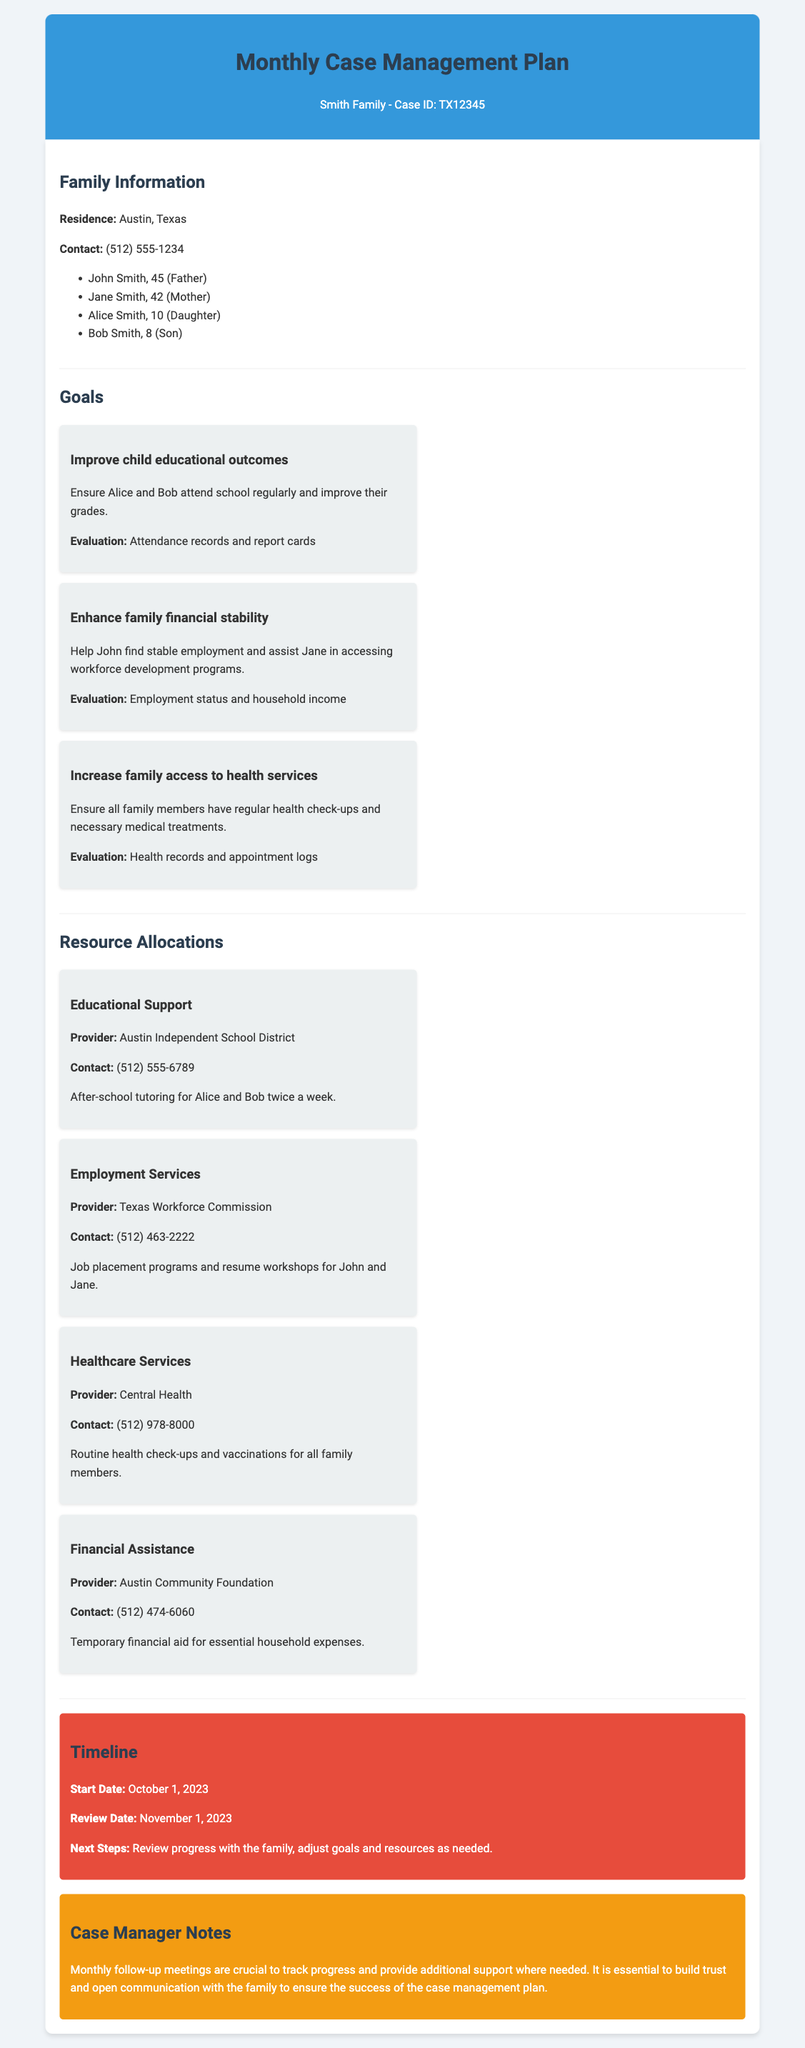what is the family surname? The family surname is indicated in the case management plan title.
Answer: Smith how many children are in the Smith family? The document lists the family members including Alice and Bob as children.
Answer: two what goal is related to educational outcomes? The goal section specifies a goal to improve educational outcomes for Alice and Bob.
Answer: Improve child educational outcomes which organization provides employment services? The resource allocations section identifies the Texas Workforce Commission for employment services.
Answer: Texas Workforce Commission what is the start date of the case management plan? The timeline section provides the start date as October 1, 2023.
Answer: October 1, 2023 what type of assistance is provided by Austin Community Foundation? The resource allocation section mentions the specific type of assistance provided by this foundation.
Answer: Financial Assistance how often will the family receive tutoring? The document specifies the frequency of tutoring for the children in the goals section.
Answer: twice a week what is a necessary action after the review date? The timeline suggests an action to be taken after the review date.
Answer: Review progress with the family what is emphasized in the case manager notes? The notes highlight the importance of follow-up meetings and relationship building.
Answer: Trust and open communication 